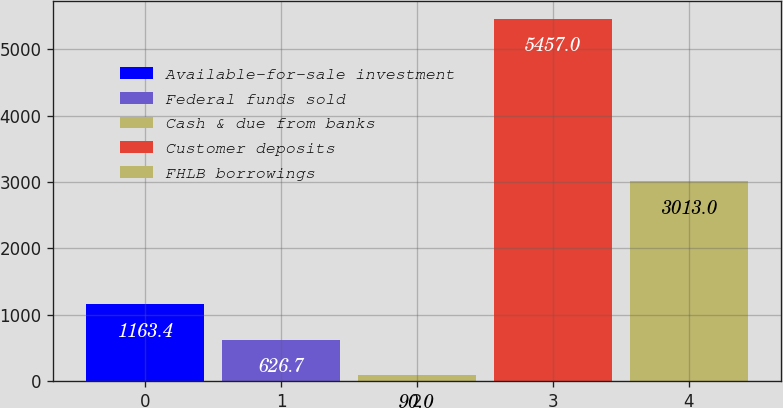Convert chart to OTSL. <chart><loc_0><loc_0><loc_500><loc_500><bar_chart><fcel>Available-for-sale investment<fcel>Federal funds sold<fcel>Cash & due from banks<fcel>Customer deposits<fcel>FHLB borrowings<nl><fcel>1163.4<fcel>626.7<fcel>90<fcel>5457<fcel>3013<nl></chart> 